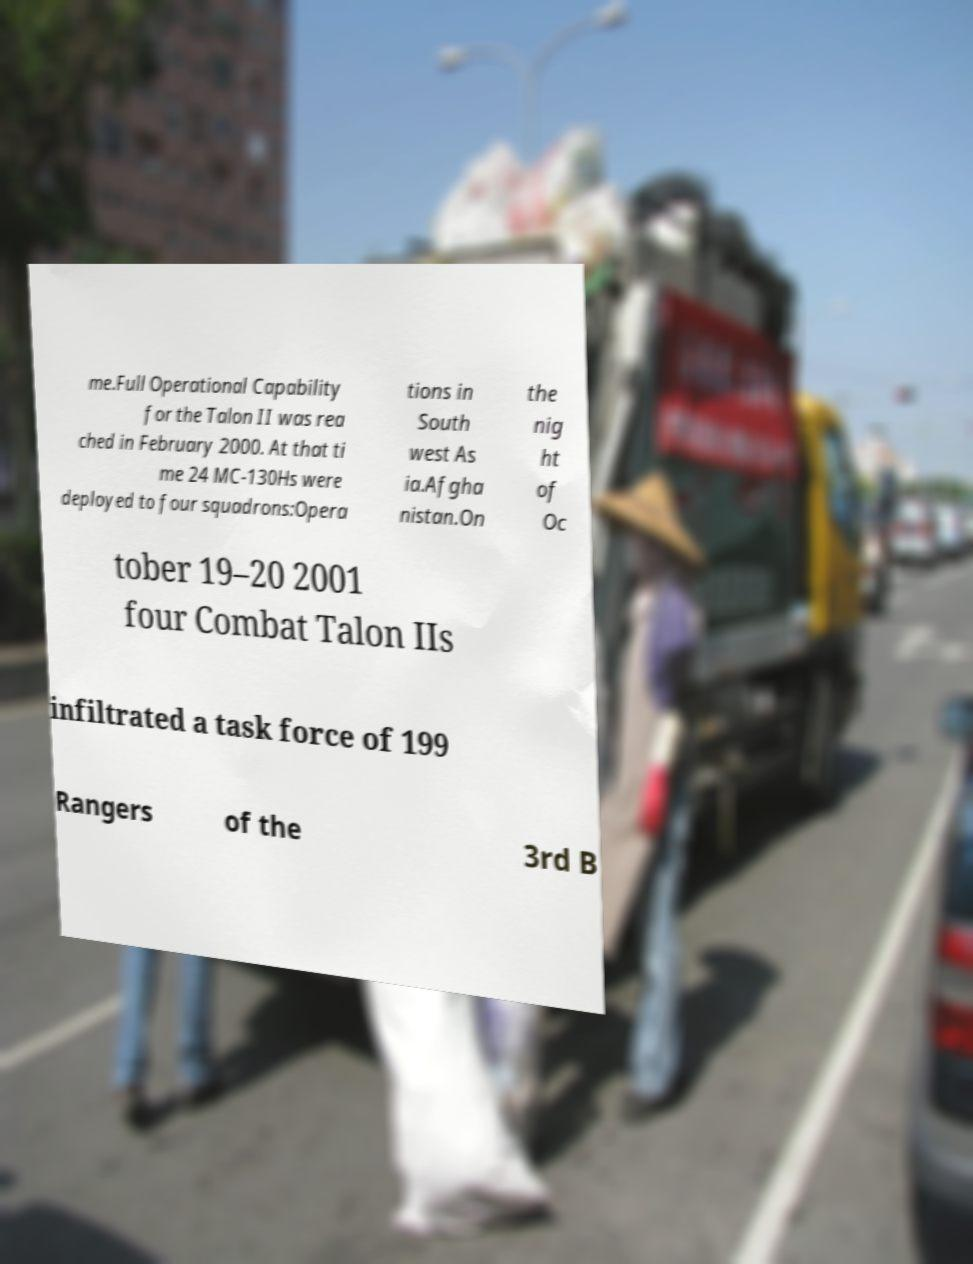Could you extract and type out the text from this image? me.Full Operational Capability for the Talon II was rea ched in February 2000. At that ti me 24 MC-130Hs were deployed to four squadrons:Opera tions in South west As ia.Afgha nistan.On the nig ht of Oc tober 19–20 2001 four Combat Talon IIs infiltrated a task force of 199 Rangers of the 3rd B 